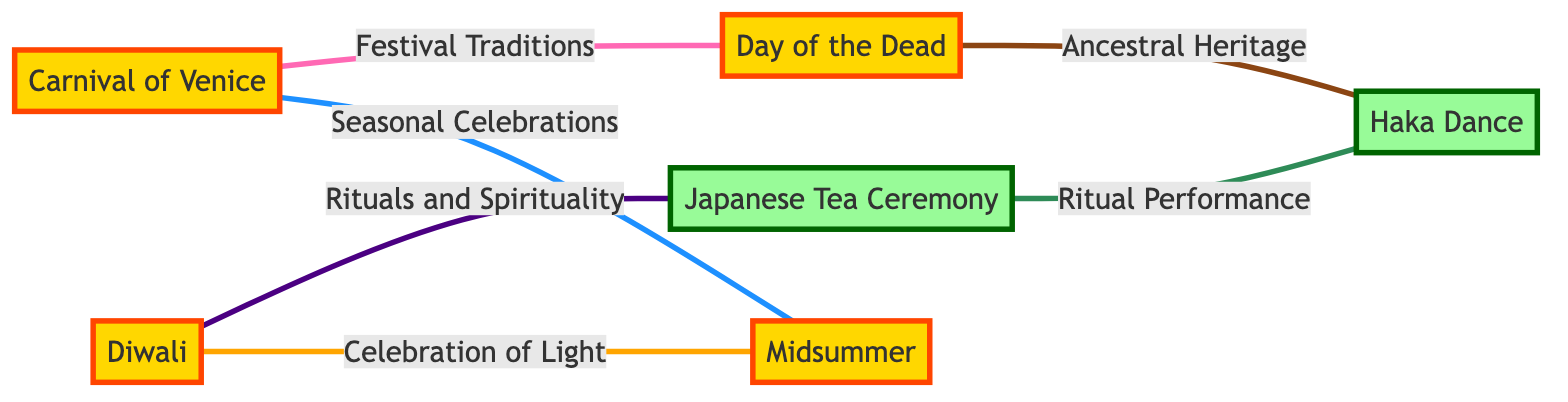What is the first festival listed in the diagram? The diagram lists the "Carnival of Venice" as the first festival under the nodes section.
Answer: Carnival of Venice How many festivals are there in the diagram? By counting the nodes labeled as festivals, there are five festivals: Carnival of Venice, Day of the Dead, Diwali, Midsummer, and each can be identified as part of the festive nodes.
Answer: 5 Which two festivals are directly connected by the label "Festival Traditions"? The nodes connected by the edge labeled "Festival Traditions" are the "Carnival of Venice" and "Day of the Dead".
Answer: Carnival of Venice and Day of the Dead What is the relationship between Diwali and the Japanese Tea Ceremony? The edge labeled "Rituals and Spirituality" connects Diwali and the Japanese Tea Ceremony, indicating they share that specific relationship.
Answer: Rituals and Spirituality How many edges are there in total in the diagram? By counting the relationships (edges) that connect the nodes, there are six edges present in the diagram.
Answer: 6 Which festival is associated with "Ancestral Heritage"? The edge labeled "Ancestral Heritage" connects the "Day of the Dead" to the "Haka Dance", indicating that "Day of the Dead" is associated with it.
Answer: Day of the Dead What connection links Midsummer and Carnival of Venice? The edge labeled "Seasonal Celebrations" links Midsummer and Carnival of Venice, defining their connection.
Answer: Seasonal Celebrations Which two cultures are represented by the Haka Dance and the Japanese Tea Ceremony? The Haka Dance represents Māori culture from New Zealand, and the Japanese Tea Ceremony represents Japanese culture, highlighting their distinct cultural origins.
Answer: Māori culture and Japanese culture How many unique cultural practices are represented in the diagram? To determine the unique cultural practices, we identify each festival and ceremony listed in the nodes, and since all identified are distinct, the count is six unique practices represented.
Answer: 6 